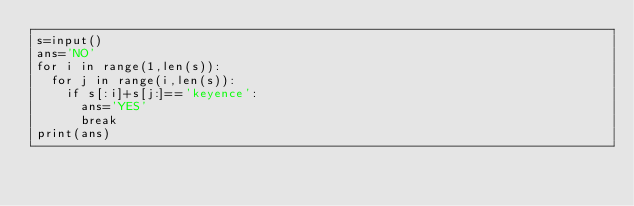Convert code to text. <code><loc_0><loc_0><loc_500><loc_500><_Python_>s=input()
ans='NO'
for i in range(1,len(s)):
  for j in range(i,len(s)):
    if s[:i]+s[j:]=='keyence':
      ans='YES'
      break
print(ans)</code> 